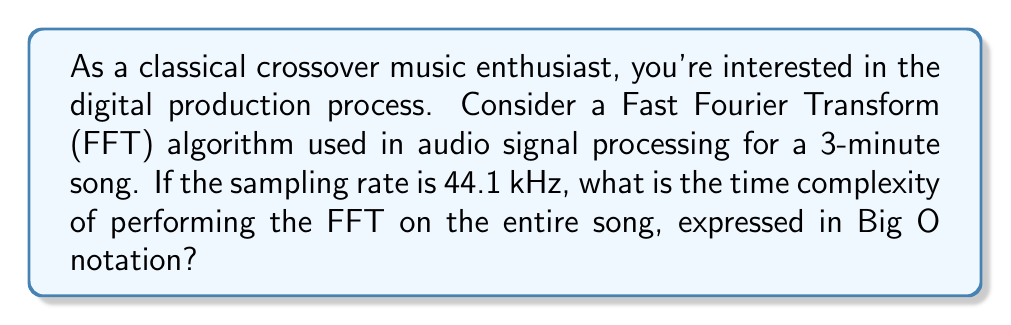Help me with this question. To solve this problem, let's break it down step-by-step:

1. First, calculate the total number of samples in the song:
   - Duration: 3 minutes = 180 seconds
   - Sampling rate: 44.1 kHz = 44,100 samples/second
   - Total samples: $n = 180 \times 44100 = 7,938,000$ samples

2. The time complexity of the Fast Fourier Transform (FFT) algorithm is $O(N \log N)$, where $N$ is the number of samples being processed.

3. However, the FFT is typically performed on smaller chunks of the audio, not the entire song at once. The standard chunk size for audio processing is often 1024 or 2048 samples.

4. Let's assume a chunk size of 2048 samples. We need to calculate how many chunks are in the song:
   $\text{Number of chunks} = \lceil \frac{7,938,000}{2048} \rceil = 3,876$

5. For each chunk, the time complexity is $O(2048 \log 2048)$.

6. We perform this operation 3,876 times, so the total time complexity is:
   $O(3876 \times 2048 \log 2048)$

7. Simplifying:
   $O(3876 \times 2048 \log 2048) = O(7,938,048 \log 2048)$

8. Since 7,938,048 is very close to our original $n$ (7,938,000), we can approximate this as:
   $O(n \log 2048)$

9. In Big O notation, we can treat 2048 as a constant, so $\log 2048$ becomes a constant factor.

Therefore, the final time complexity can be expressed as $O(n)$.
Answer: $O(n)$ 